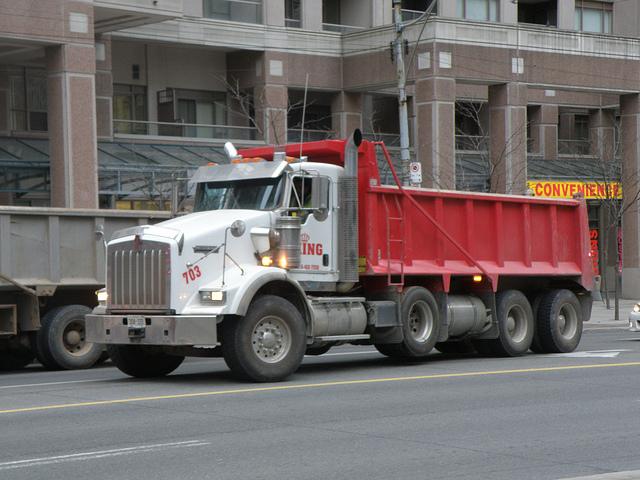Will the truck go straight ahead?
Concise answer only. Yes. What is written in yellow letters on the red background?
Keep it brief. Convenience. How many tires does this truck need?
Concise answer only. 8. What color is the truck?
Keep it brief. Red and white. Is there any light in the truck?
Answer briefly. Yes. What is the number on the front of this truck?
Short answer required. 703. 